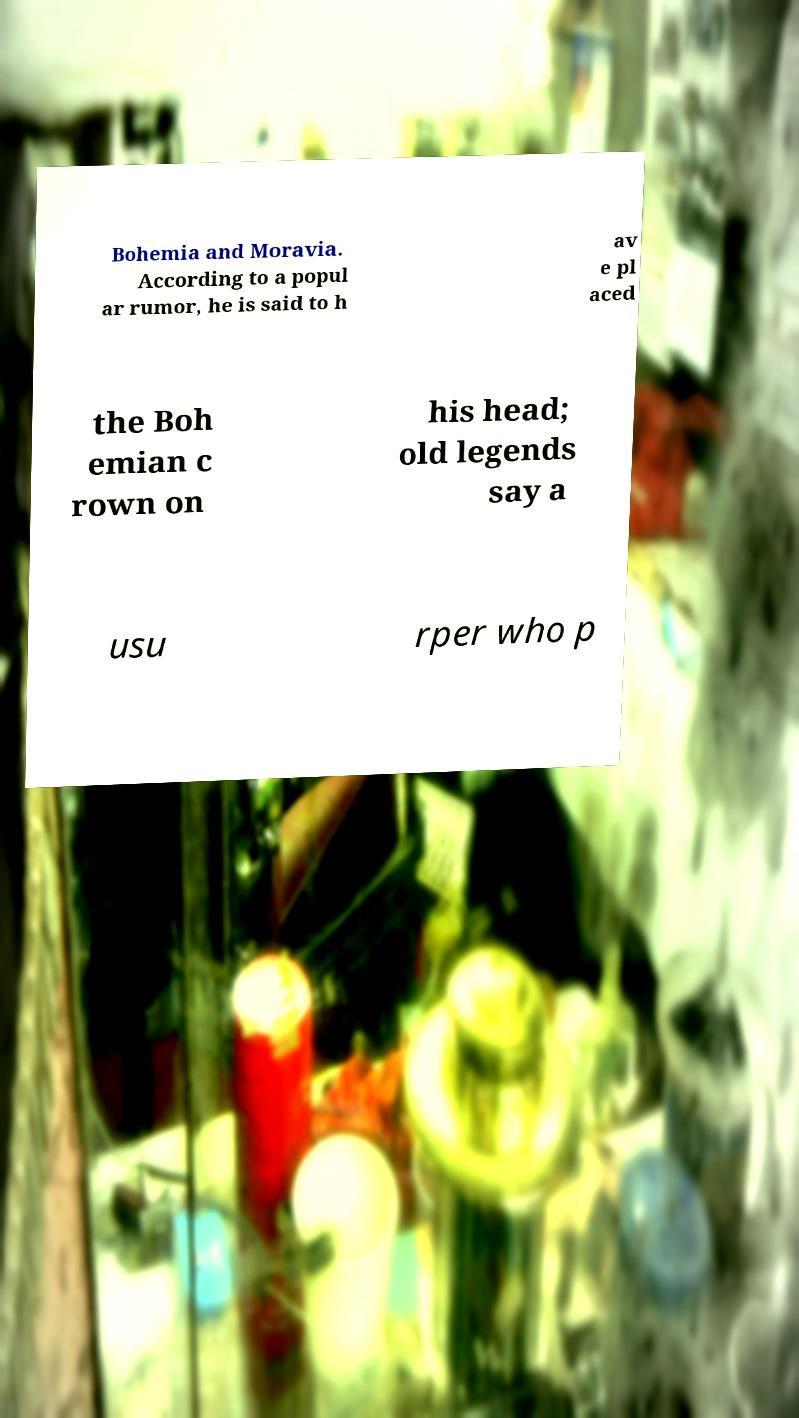Please identify and transcribe the text found in this image. Bohemia and Moravia. According to a popul ar rumor, he is said to h av e pl aced the Boh emian c rown on his head; old legends say a usu rper who p 